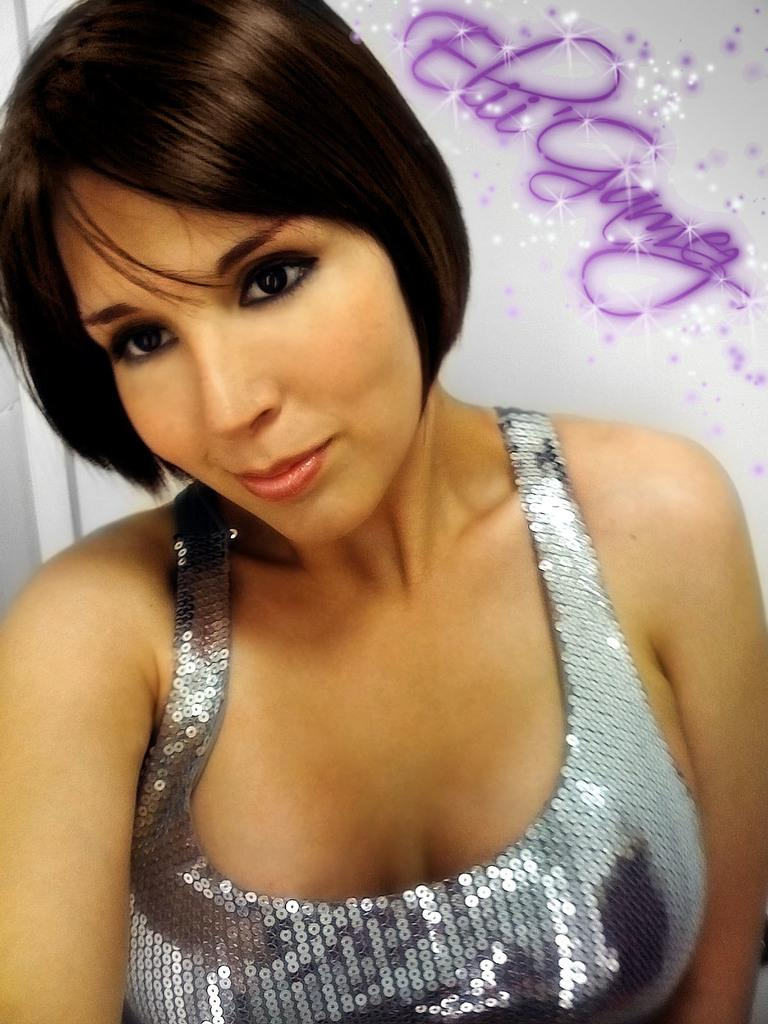Who is present in the image? There is a lady in the image. What can be seen behind the lady? There is text visible behind the lady. What type of things can be found in the cellar in the image? There is no cellar present in the image; it only features a lady and text. Where is the market located in the image? There is no market present in the image; it only features a lady and text. 